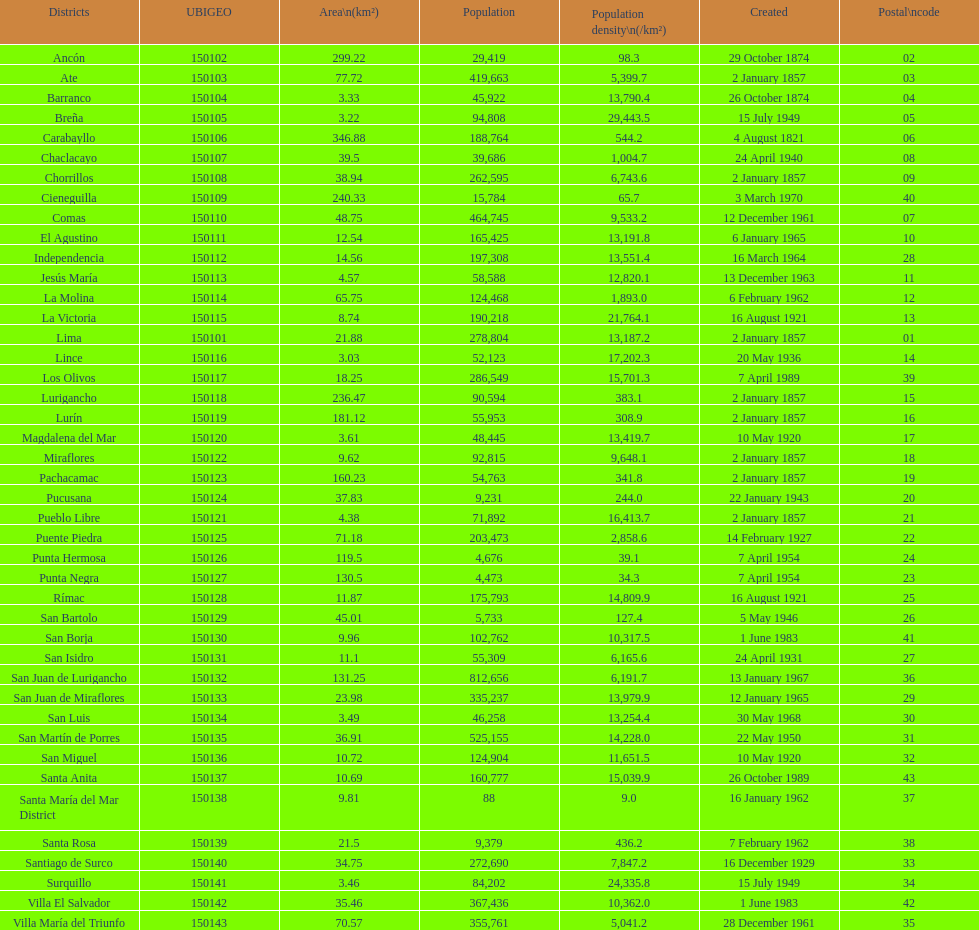What is the count of districts formed in the 20th century? 32. 